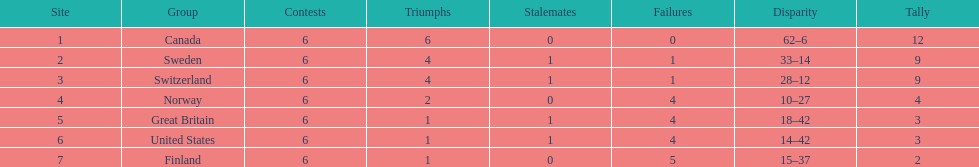How many teams won 6 matches? 1. Give me the full table as a dictionary. {'header': ['Site', 'Group', 'Contests', 'Triumphs', 'Stalemates', 'Failures', 'Disparity', 'Tally'], 'rows': [['1', 'Canada', '6', '6', '0', '0', '62–6', '12'], ['2', 'Sweden', '6', '4', '1', '1', '33–14', '9'], ['3', 'Switzerland', '6', '4', '1', '1', '28–12', '9'], ['4', 'Norway', '6', '2', '0', '4', '10–27', '4'], ['5', 'Great Britain', '6', '1', '1', '4', '18–42', '3'], ['6', 'United States', '6', '1', '1', '4', '14–42', '3'], ['7', 'Finland', '6', '1', '0', '5', '15–37', '2']]} 